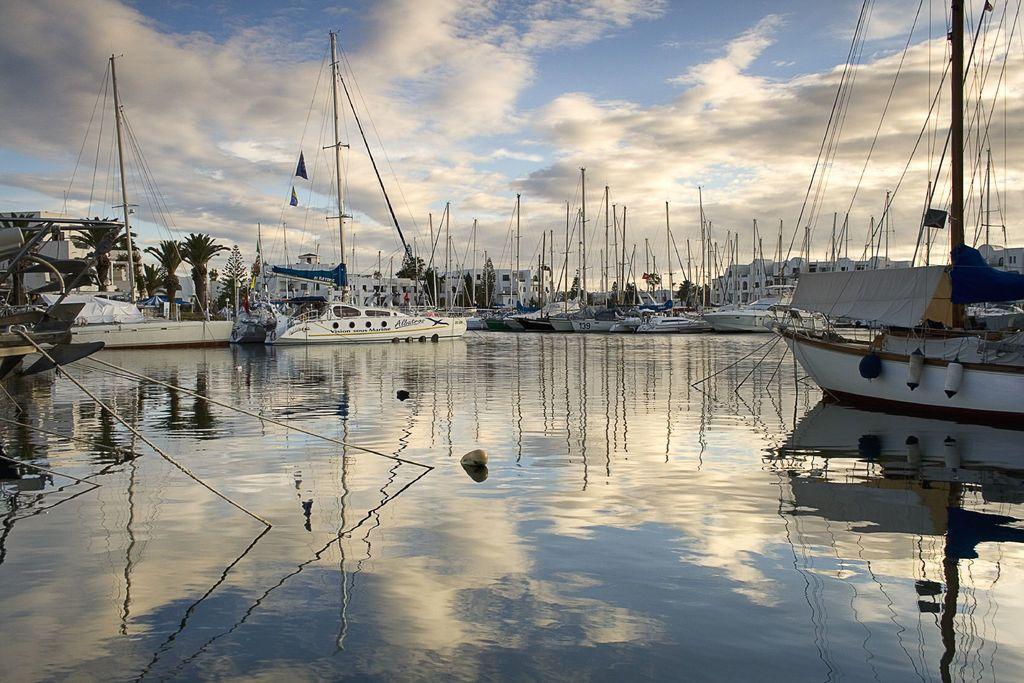Could you give a brief overview of what you see in this image? There are plenty of ships floating on the the water and behind the ships there are a lot of houses and trees. 